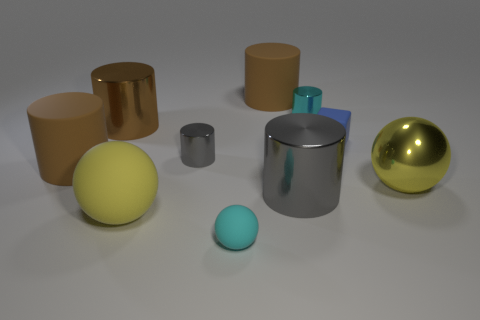Subtract all rubber cylinders. How many cylinders are left? 4 Subtract all brown cylinders. How many cylinders are left? 3 Subtract 2 spheres. How many spheres are left? 1 Subtract all blue cylinders. How many yellow spheres are left? 2 Subtract all blocks. How many objects are left? 9 Subtract all yellow cubes. Subtract all brown cylinders. How many cubes are left? 1 Subtract all big gray metal cylinders. Subtract all small metallic objects. How many objects are left? 7 Add 3 cyan rubber balls. How many cyan rubber balls are left? 4 Add 8 big gray objects. How many big gray objects exist? 9 Subtract 0 yellow cylinders. How many objects are left? 10 